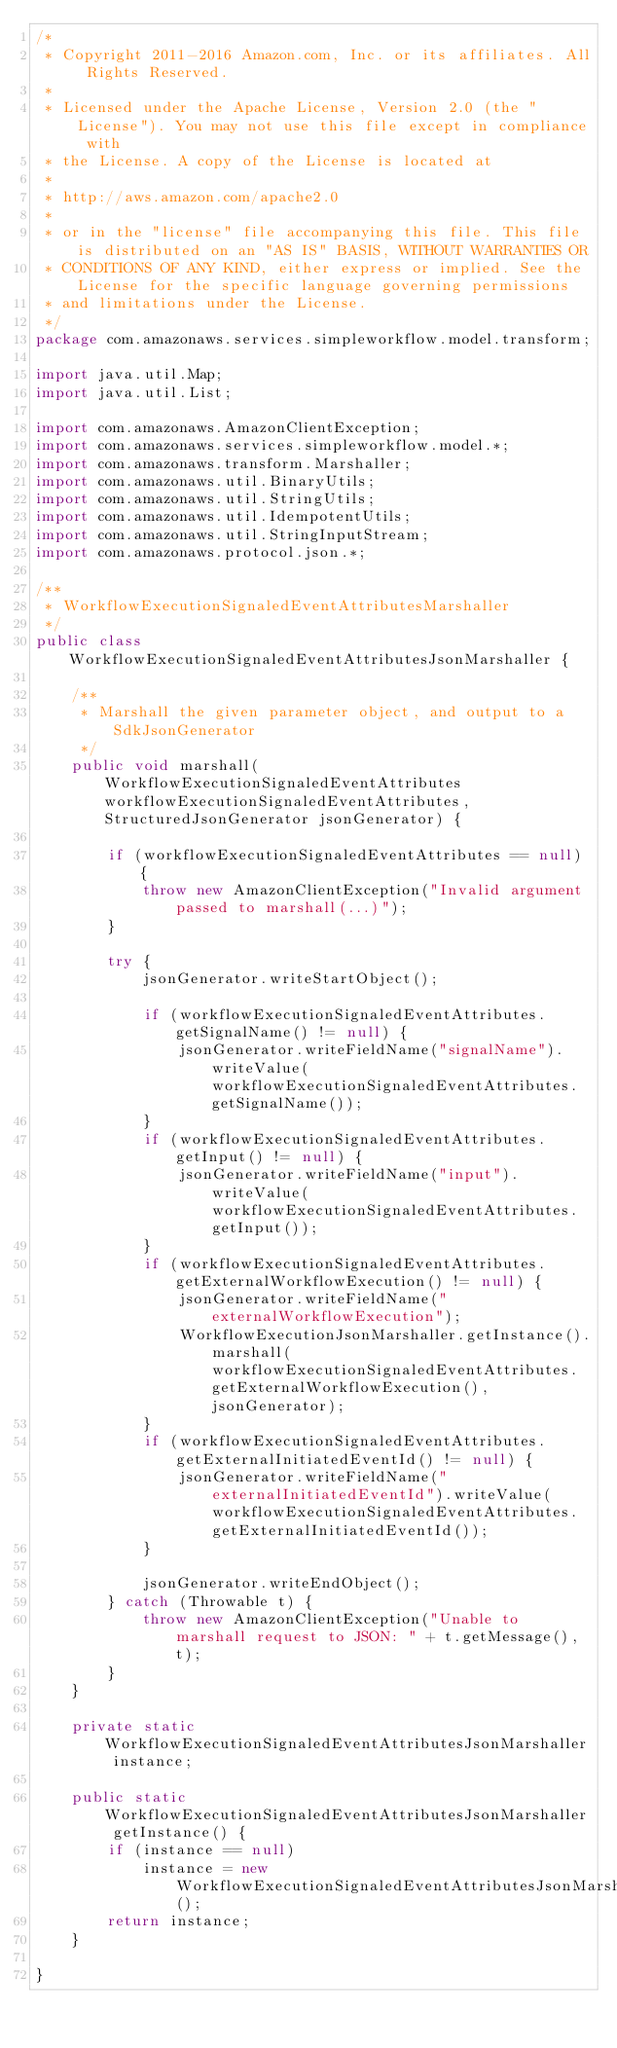Convert code to text. <code><loc_0><loc_0><loc_500><loc_500><_Java_>/*
 * Copyright 2011-2016 Amazon.com, Inc. or its affiliates. All Rights Reserved.
 * 
 * Licensed under the Apache License, Version 2.0 (the "License"). You may not use this file except in compliance with
 * the License. A copy of the License is located at
 * 
 * http://aws.amazon.com/apache2.0
 * 
 * or in the "license" file accompanying this file. This file is distributed on an "AS IS" BASIS, WITHOUT WARRANTIES OR
 * CONDITIONS OF ANY KIND, either express or implied. See the License for the specific language governing permissions
 * and limitations under the License.
 */
package com.amazonaws.services.simpleworkflow.model.transform;

import java.util.Map;
import java.util.List;

import com.amazonaws.AmazonClientException;
import com.amazonaws.services.simpleworkflow.model.*;
import com.amazonaws.transform.Marshaller;
import com.amazonaws.util.BinaryUtils;
import com.amazonaws.util.StringUtils;
import com.amazonaws.util.IdempotentUtils;
import com.amazonaws.util.StringInputStream;
import com.amazonaws.protocol.json.*;

/**
 * WorkflowExecutionSignaledEventAttributesMarshaller
 */
public class WorkflowExecutionSignaledEventAttributesJsonMarshaller {

    /**
     * Marshall the given parameter object, and output to a SdkJsonGenerator
     */
    public void marshall(WorkflowExecutionSignaledEventAttributes workflowExecutionSignaledEventAttributes, StructuredJsonGenerator jsonGenerator) {

        if (workflowExecutionSignaledEventAttributes == null) {
            throw new AmazonClientException("Invalid argument passed to marshall(...)");
        }

        try {
            jsonGenerator.writeStartObject();

            if (workflowExecutionSignaledEventAttributes.getSignalName() != null) {
                jsonGenerator.writeFieldName("signalName").writeValue(workflowExecutionSignaledEventAttributes.getSignalName());
            }
            if (workflowExecutionSignaledEventAttributes.getInput() != null) {
                jsonGenerator.writeFieldName("input").writeValue(workflowExecutionSignaledEventAttributes.getInput());
            }
            if (workflowExecutionSignaledEventAttributes.getExternalWorkflowExecution() != null) {
                jsonGenerator.writeFieldName("externalWorkflowExecution");
                WorkflowExecutionJsonMarshaller.getInstance().marshall(workflowExecutionSignaledEventAttributes.getExternalWorkflowExecution(), jsonGenerator);
            }
            if (workflowExecutionSignaledEventAttributes.getExternalInitiatedEventId() != null) {
                jsonGenerator.writeFieldName("externalInitiatedEventId").writeValue(workflowExecutionSignaledEventAttributes.getExternalInitiatedEventId());
            }

            jsonGenerator.writeEndObject();
        } catch (Throwable t) {
            throw new AmazonClientException("Unable to marshall request to JSON: " + t.getMessage(), t);
        }
    }

    private static WorkflowExecutionSignaledEventAttributesJsonMarshaller instance;

    public static WorkflowExecutionSignaledEventAttributesJsonMarshaller getInstance() {
        if (instance == null)
            instance = new WorkflowExecutionSignaledEventAttributesJsonMarshaller();
        return instance;
    }

}
</code> 